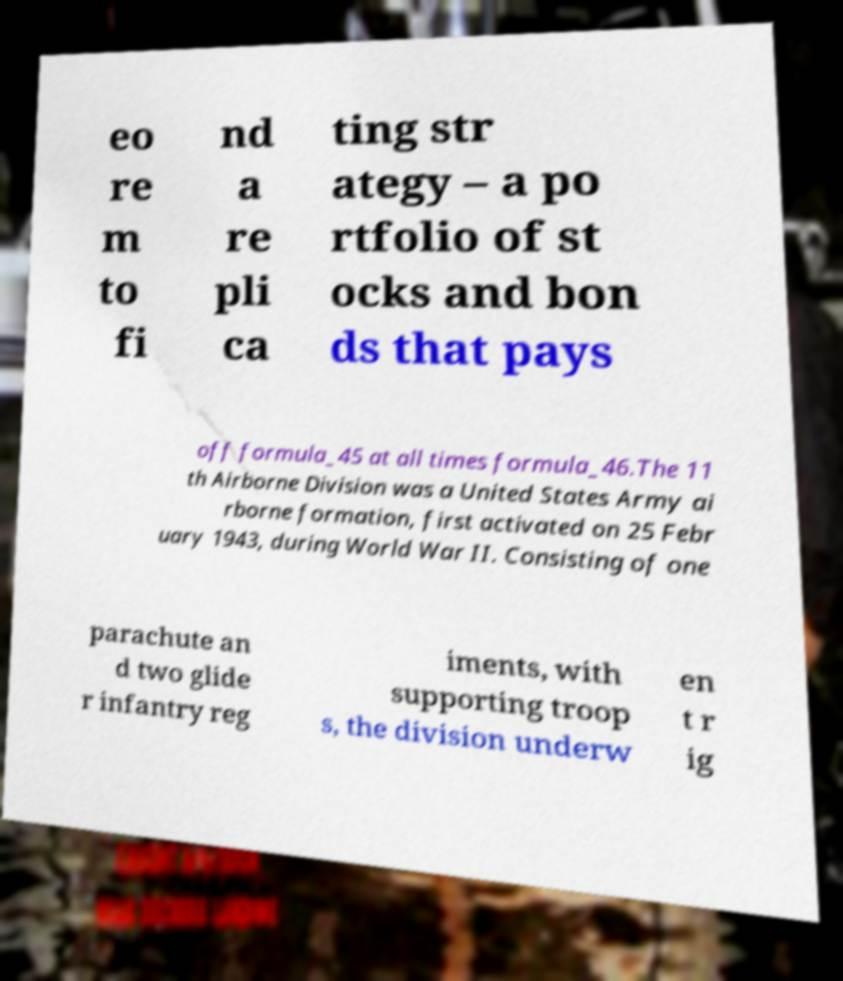Please read and relay the text visible in this image. What does it say? eo re m to fi nd a re pli ca ting str ategy – a po rtfolio of st ocks and bon ds that pays off formula_45 at all times formula_46.The 11 th Airborne Division was a United States Army ai rborne formation, first activated on 25 Febr uary 1943, during World War II. Consisting of one parachute an d two glide r infantry reg iments, with supporting troop s, the division underw en t r ig 